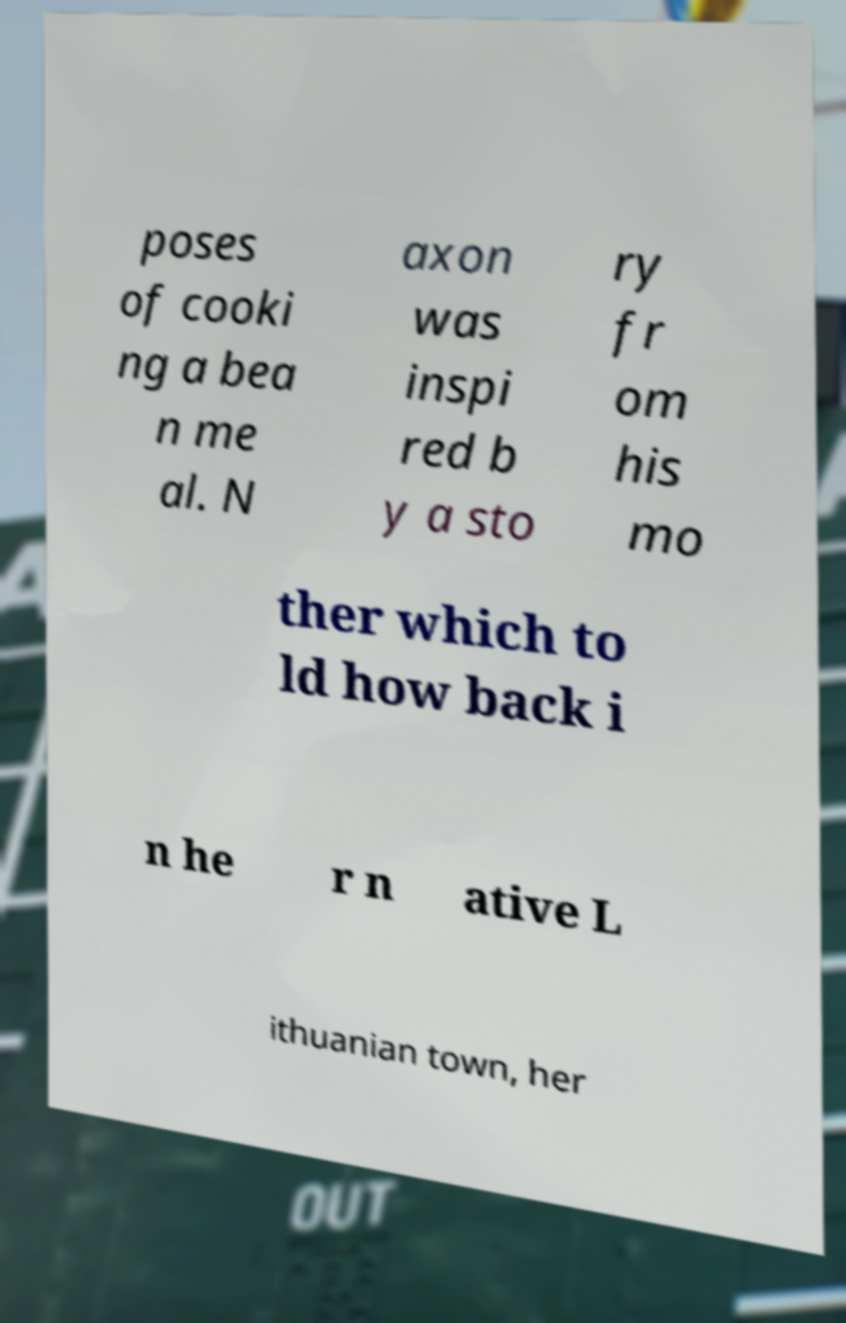I need the written content from this picture converted into text. Can you do that? poses of cooki ng a bea n me al. N axon was inspi red b y a sto ry fr om his mo ther which to ld how back i n he r n ative L ithuanian town, her 